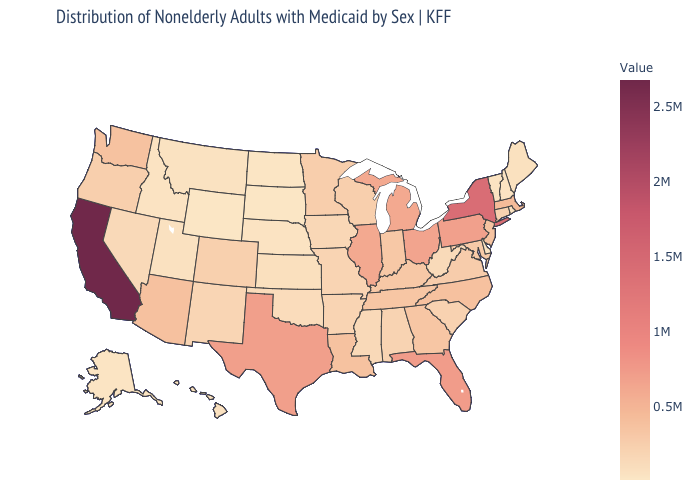Does the map have missing data?
Give a very brief answer. No. Does California have the highest value in the USA?
Short answer required. Yes. Does California have the highest value in the USA?
Write a very short answer. Yes. 